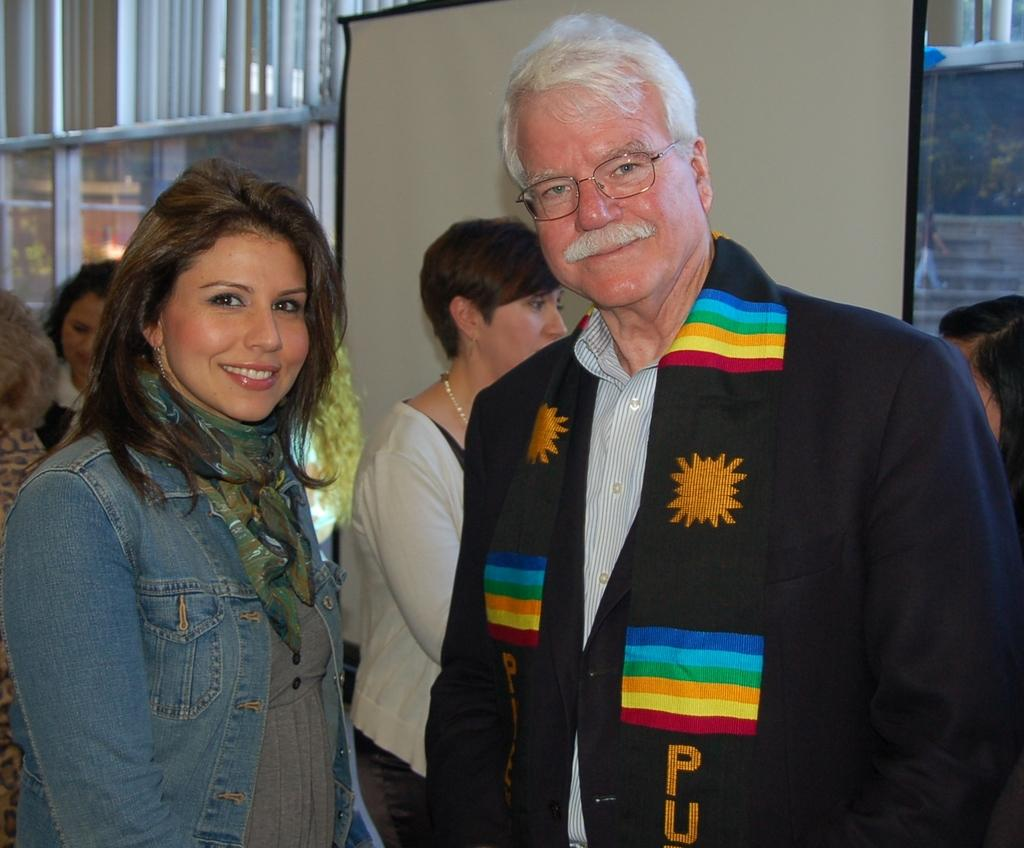How many people with different color dresses can be seen in the image? There are people with different color dresses in the image, but the exact number cannot be determined from the provided facts. What is located in the background of the image? There is a board and a glass in the background of the image. What can be seen through the glass in the image? A person, stairs, and trees can be seen through the glass in the image. What type of mint is growing in the yard visible through the glass? There is no mention of a yard or mint in the provided facts, so it cannot be determined if mint is present or growing in the image. 